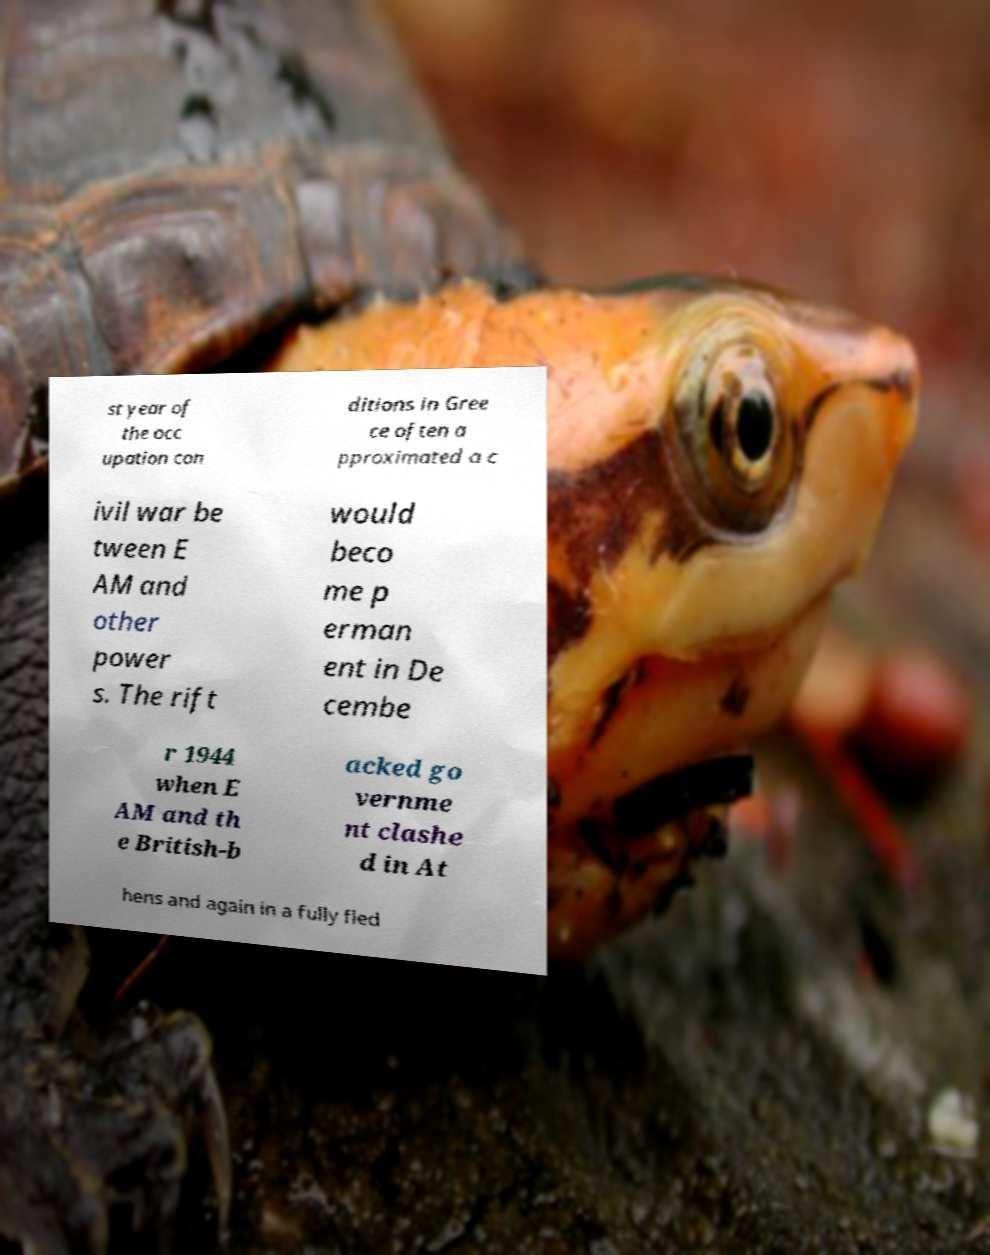Could you extract and type out the text from this image? st year of the occ upation con ditions in Gree ce often a pproximated a c ivil war be tween E AM and other power s. The rift would beco me p erman ent in De cembe r 1944 when E AM and th e British-b acked go vernme nt clashe d in At hens and again in a fully fled 